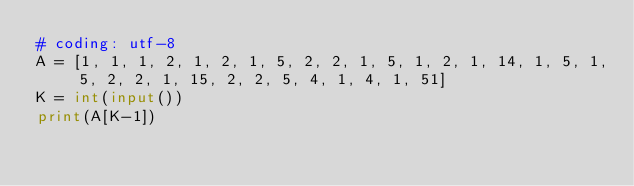Convert code to text. <code><loc_0><loc_0><loc_500><loc_500><_Python_># coding: utf-8
A = [1, 1, 1, 2, 1, 2, 1, 5, 2, 2, 1, 5, 1, 2, 1, 14, 1, 5, 1, 5, 2, 2, 1, 15, 2, 2, 5, 4, 1, 4, 1, 51]
K = int(input())
print(A[K-1])</code> 